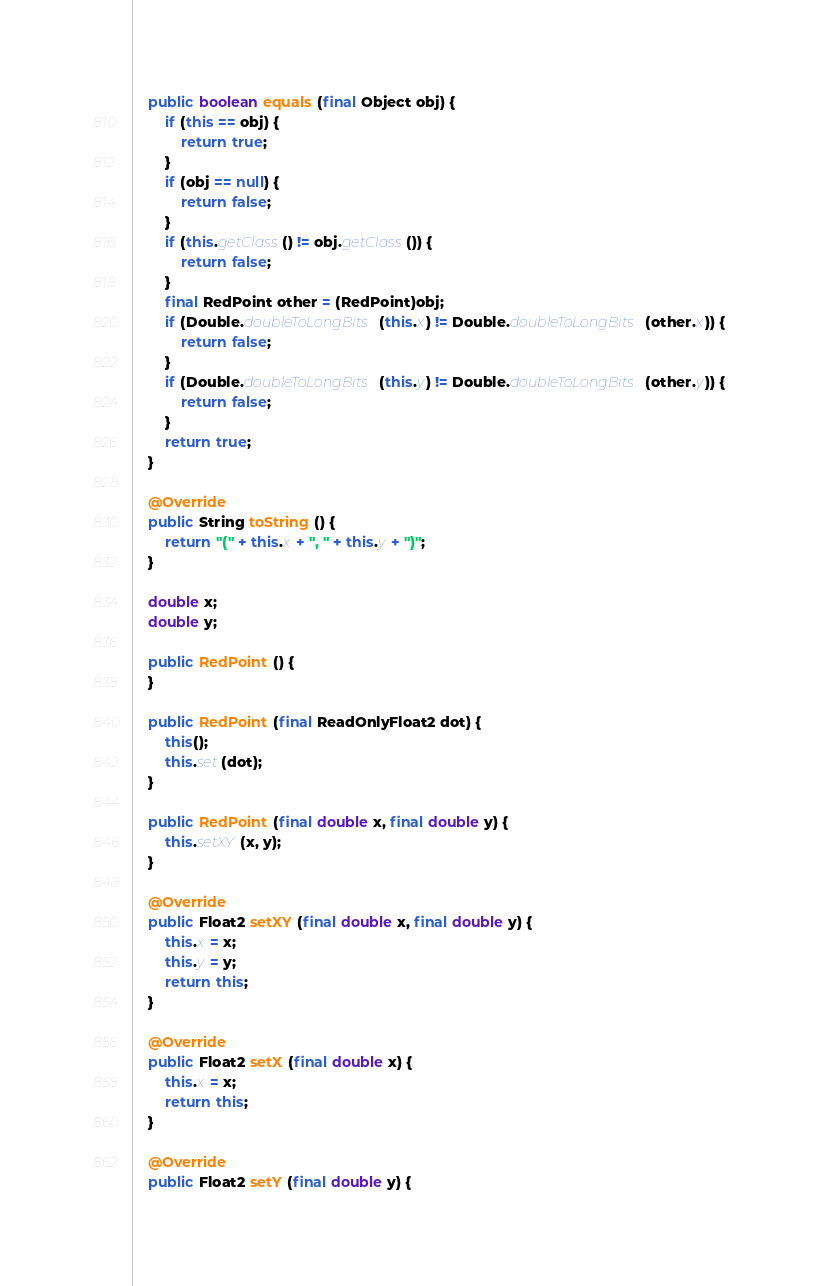<code> <loc_0><loc_0><loc_500><loc_500><_Java_>	public boolean equals (final Object obj) {
		if (this == obj) {
			return true;
		}
		if (obj == null) {
			return false;
		}
		if (this.getClass() != obj.getClass()) {
			return false;
		}
		final RedPoint other = (RedPoint)obj;
		if (Double.doubleToLongBits(this.x) != Double.doubleToLongBits(other.x)) {
			return false;
		}
		if (Double.doubleToLongBits(this.y) != Double.doubleToLongBits(other.y)) {
			return false;
		}
		return true;
	}

	@Override
	public String toString () {
		return "(" + this.x + ", " + this.y + ")";
	}

	double x;
	double y;

	public RedPoint () {
	}

	public RedPoint (final ReadOnlyFloat2 dot) {
		this();
		this.set(dot);
	}

	public RedPoint (final double x, final double y) {
		this.setXY(x, y);
	}

	@Override
	public Float2 setXY (final double x, final double y) {
		this.x = x;
		this.y = y;
		return this;
	}

	@Override
	public Float2 setX (final double x) {
		this.x = x;
		return this;
	}

	@Override
	public Float2 setY (final double y) {</code> 